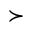<formula> <loc_0><loc_0><loc_500><loc_500>\succ</formula> 